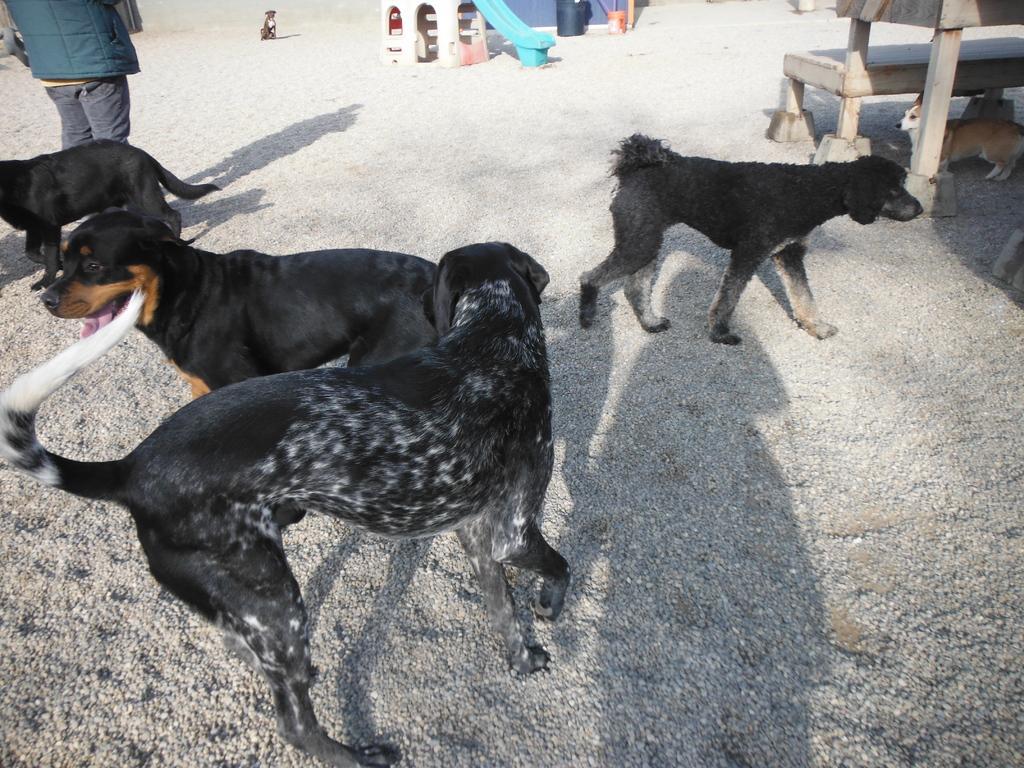Please provide a concise description of this image. In this image we can see dogs, bench, and person. 